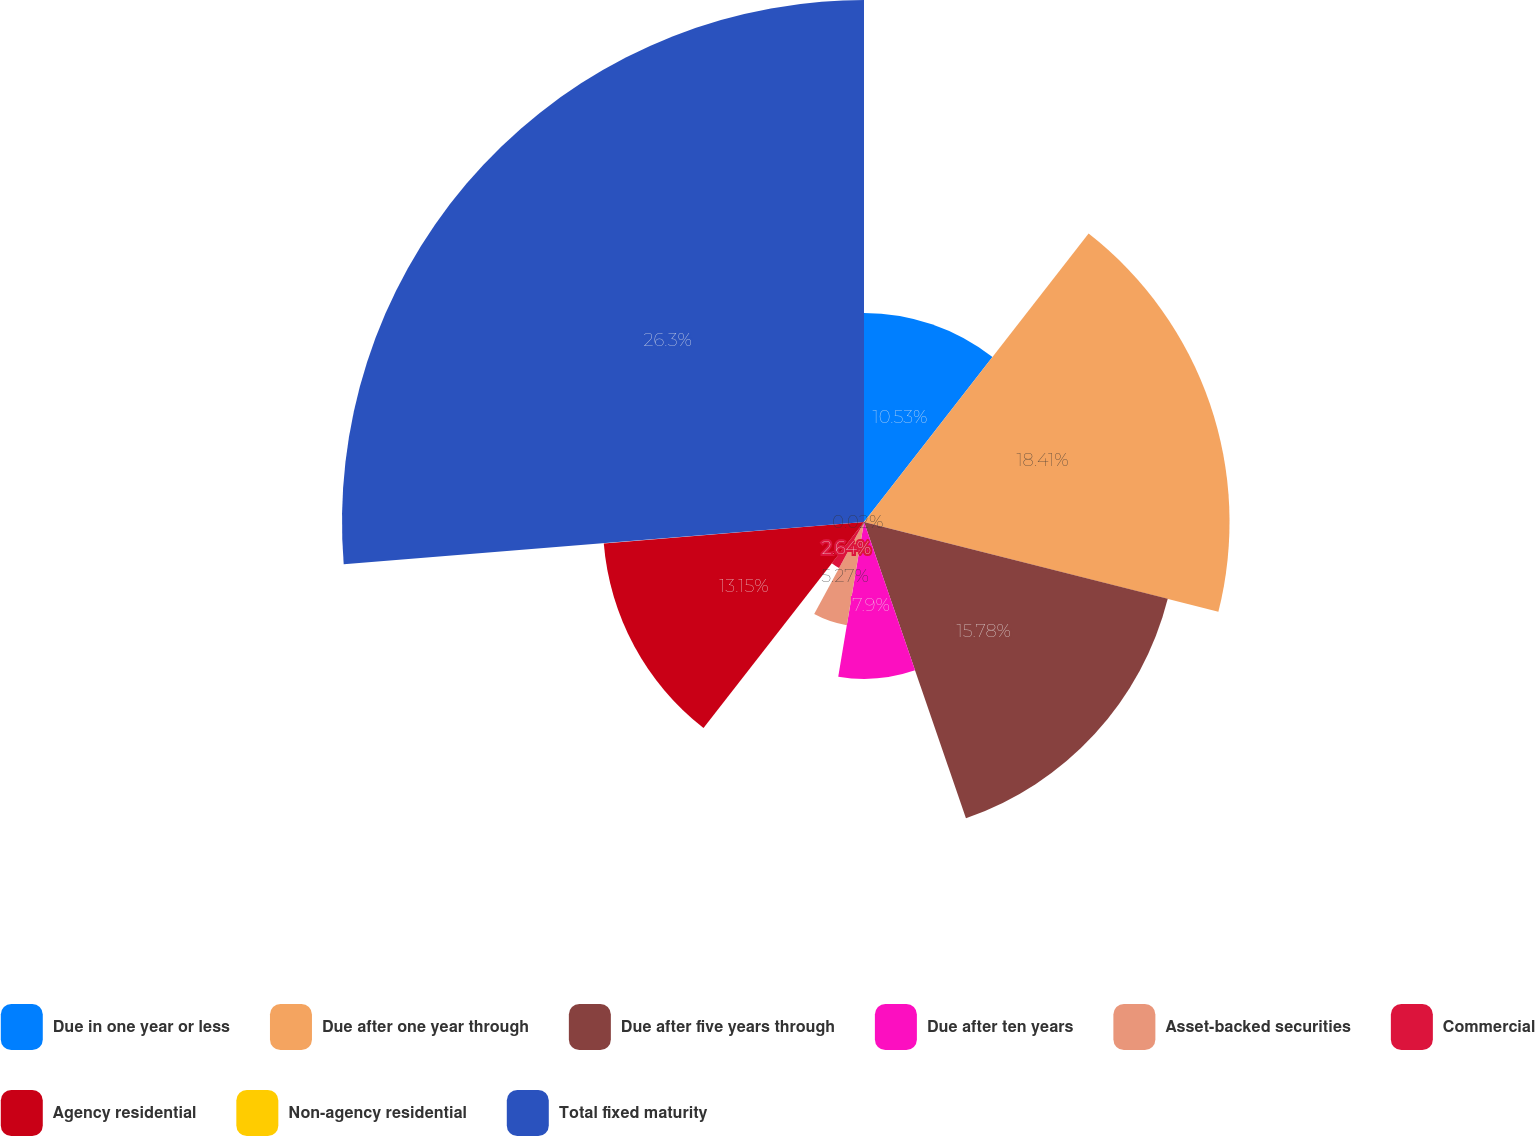<chart> <loc_0><loc_0><loc_500><loc_500><pie_chart><fcel>Due in one year or less<fcel>Due after one year through<fcel>Due after five years through<fcel>Due after ten years<fcel>Asset-backed securities<fcel>Commercial<fcel>Agency residential<fcel>Non-agency residential<fcel>Total fixed maturity<nl><fcel>10.53%<fcel>18.41%<fcel>15.78%<fcel>7.9%<fcel>5.27%<fcel>2.64%<fcel>13.15%<fcel>0.02%<fcel>26.29%<nl></chart> 